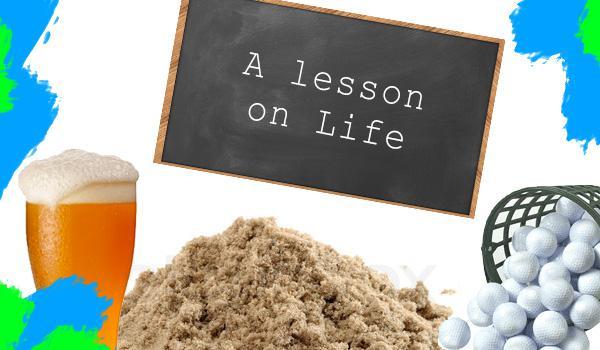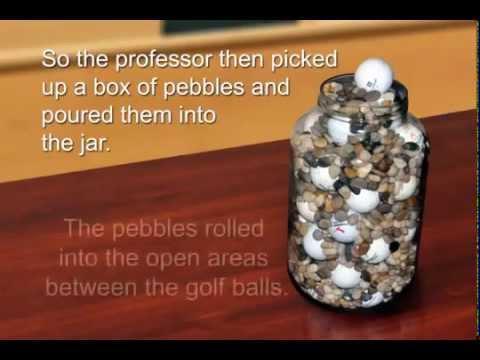The first image is the image on the left, the second image is the image on the right. Examine the images to the left and right. Is the description "In at least one image there is at least one empty and full jar of golf balls." accurate? Answer yes or no. No. The first image is the image on the left, the second image is the image on the right. Evaluate the accuracy of this statement regarding the images: "There is a glass of beer visible in one of the images.". Is it true? Answer yes or no. Yes. 